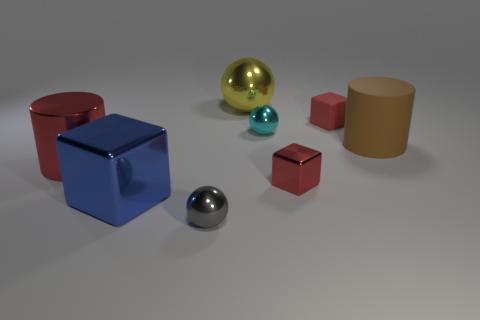Which object appears to be the largest, and what color is it? The largest object in the image is a cube, and its color is a bright blue. 